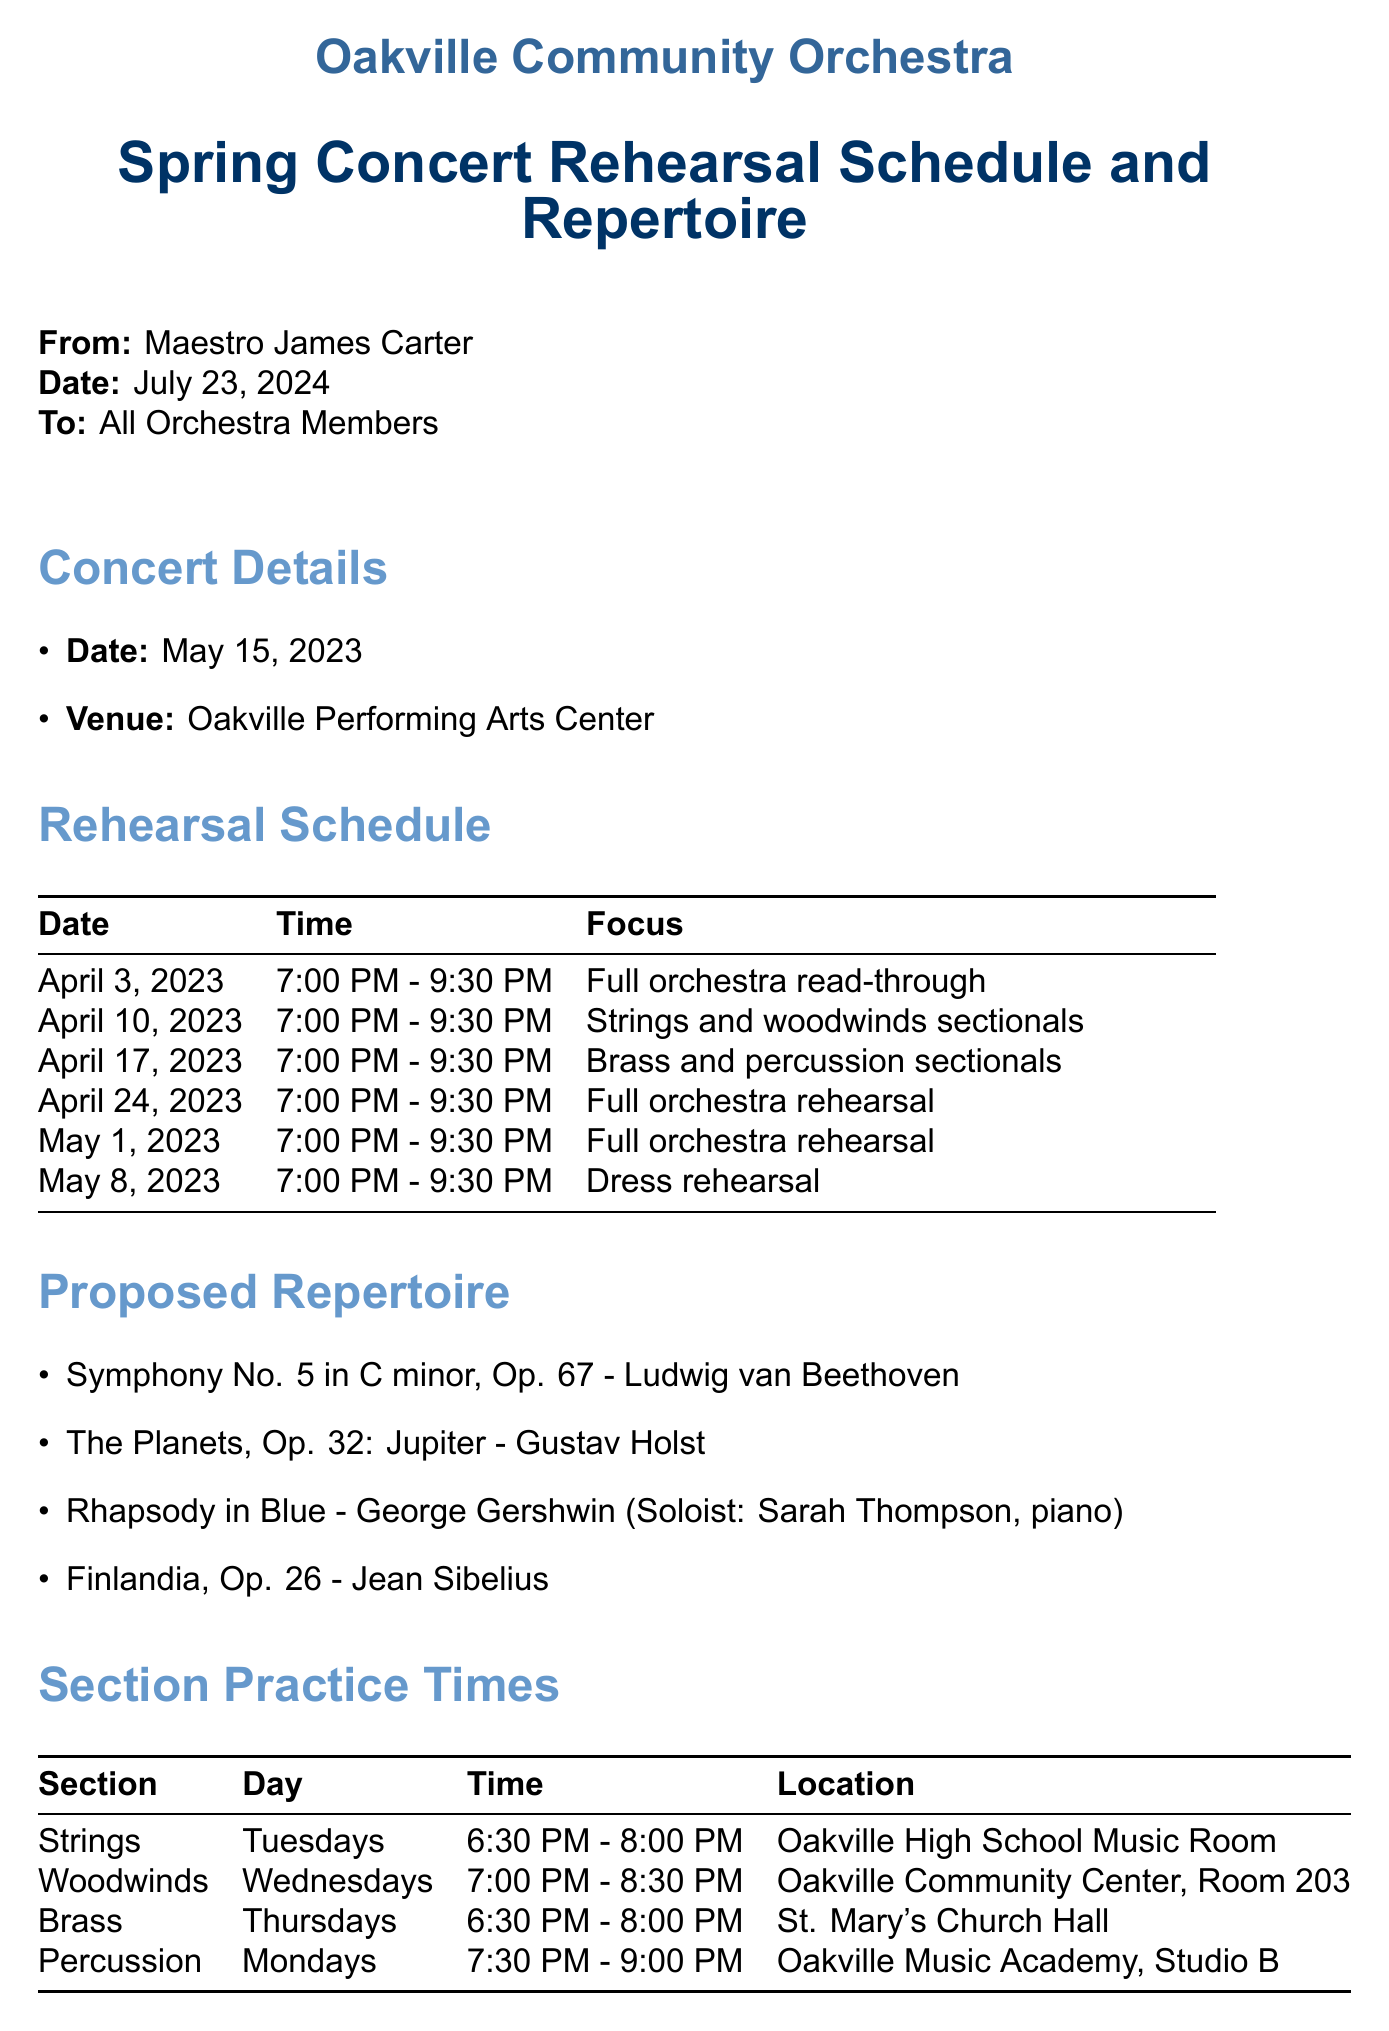What is the concert date? The concert date is specified in the document as May 15, 2023.
Answer: May 15, 2023 Who is the soloist for Rhapsody in Blue? The document mentions Sarah Thompson as the soloist for Rhapsody in Blue.
Answer: Sarah Thompson What time is the dress rehearsal? The dress rehearsal time is explicitly stated in the schedule section of the document.
Answer: 7:00 PM - 9:30 PM What is the location for the Woodwinds section practice? The location for the Woodwinds section practice is provided in the section practice times section.
Answer: Oakville Community Center, Room 203 How many rehearsals are scheduled before the concert? The total number of rehearsals can be calculated from the rehearsal schedule listed in the document.
Answer: 6 What is the attire for the concert? The document includes a note regarding concert attire for all musicians.
Answer: Black bottoms, white tops On what day do Percussion section members practice? The day of the week for Percussion section practice is clearly stated in the scheduled practice times.
Answer: Mondays What will be distributed at the first full orchestra rehearsal? The document outlines the items to be distributed during the first rehearsal.
Answer: Sheet music 